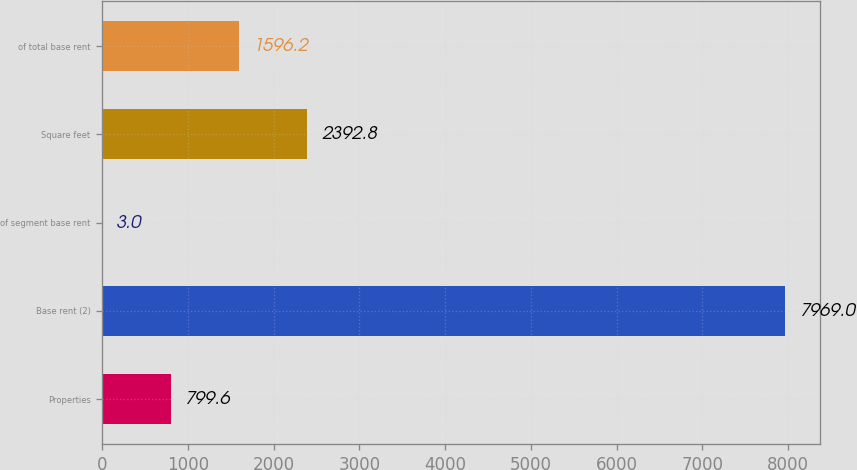Convert chart. <chart><loc_0><loc_0><loc_500><loc_500><bar_chart><fcel>Properties<fcel>Base rent (2)<fcel>of segment base rent<fcel>Square feet<fcel>of total base rent<nl><fcel>799.6<fcel>7969<fcel>3<fcel>2392.8<fcel>1596.2<nl></chart> 